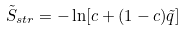Convert formula to latex. <formula><loc_0><loc_0><loc_500><loc_500>\tilde { S } _ { s t r } = - \ln [ c + ( 1 - c ) \tilde { q } ]</formula> 